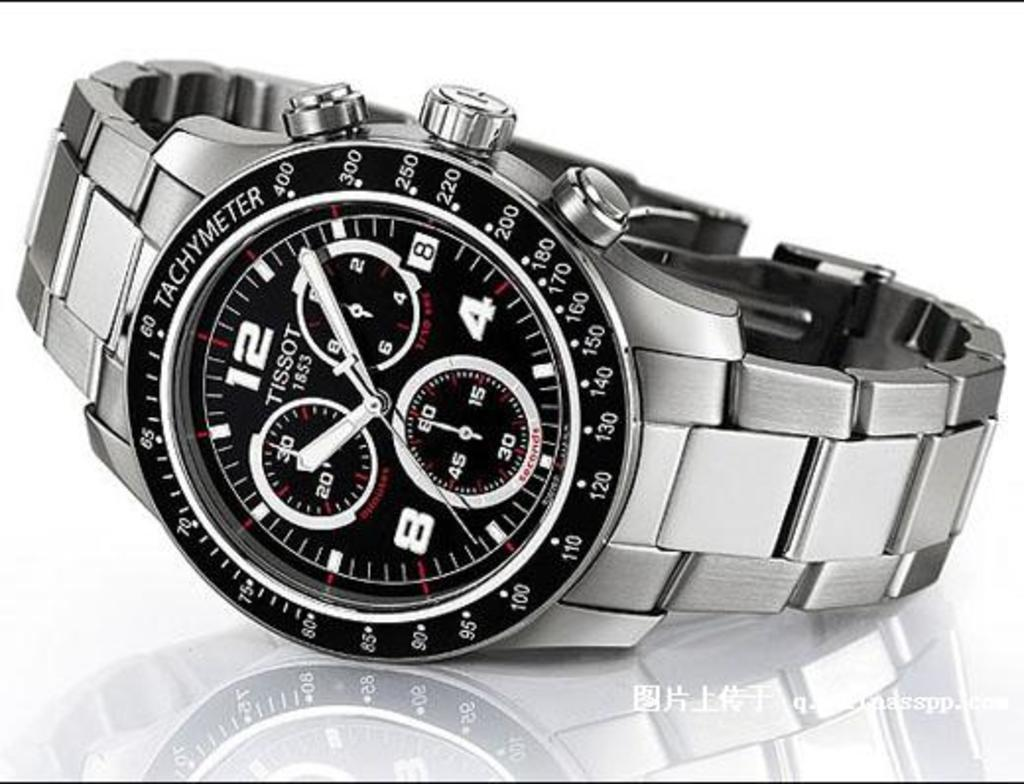<image>
Provide a brief description of the given image. A Tissot watch has the year 1853 on the face. 